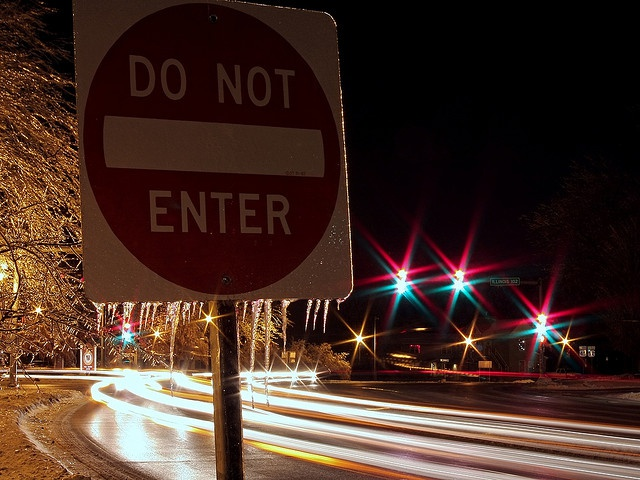Describe the objects in this image and their specific colors. I can see car in black, white, gray, darkgray, and brown tones, traffic light in black, white, lightblue, lightpink, and gray tones, traffic light in black, white, lightblue, and cyan tones, and traffic light in black, white, lightblue, lightpink, and tan tones in this image. 